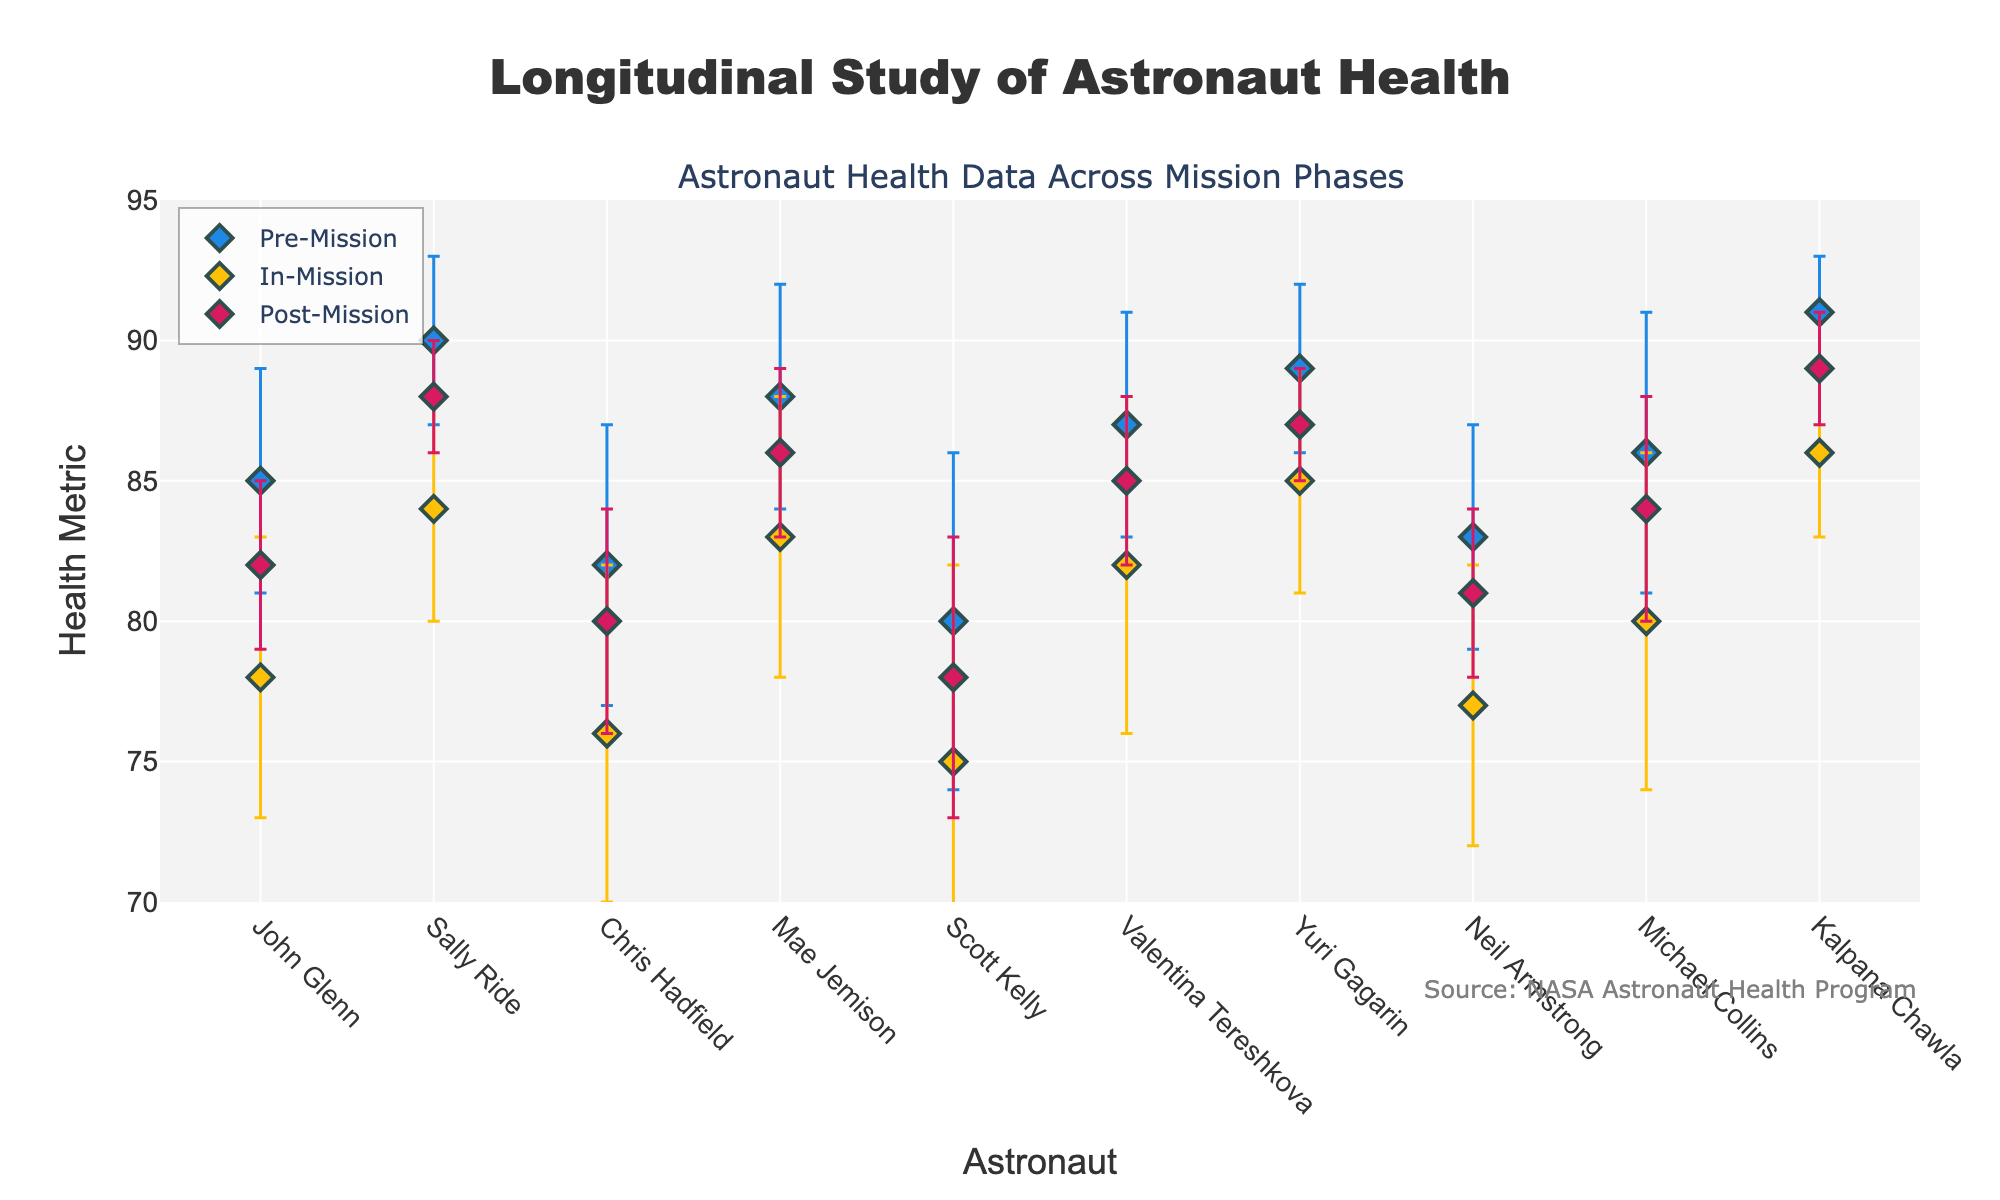What is the title of the figure? The title of the figure is shown at the top and reads "Longitudinal Study of Astronaut Health".
Answer: Longitudinal Study of Astronaut Health Which astronaut has the highest "Pre-Mission" health metric? Looking at the "Pre-Mission" data points, Kalpana Chawla has the highest value of 91.
Answer: Kalpana Chawla What is the average health metric for "In-Mission" across all astronauts? Summing up the "In-Mission" health metrics (78, 84, 76, 83, 75, 82, 85, 77, 80, 86) and then dividing by the number of data points (10), we get an average of (78+84+76+83+75+82+85+77+80+86)/10 = 80.6.
Answer: 80.6 Which mission has the largest error bar for "Post-Mission"? The largest "Post-Mission" error bar can be seen by comparing the error lengths; Scott Kelly has the largest error bar of 5.
Answer: Scott Kelly How does the "Post-Mission" health metric of Chris Hadfield compare to his "Pre-Mission" health metric? Chris Hadfield's "Pre-Mission" health metric is 82, and his "Post-Mission" health metric is 80. Comparing these two provides a difference of 82 - 80 = 2, indicating a decrease.
Answer: Decrease by 2 What is the range of the "Pre-Mission" health metrics? The highest "Pre-Mission" value is 91 (Kalpana Chawla), and the lowest is 80 (Scott Kelly). The range is calculated as 91 - 80 = 11.
Answer: 11 Which phase—"Pre-Mission", "In-Mission", or "Post-Mission"—generally shows the lowest health metrics? By observing the scatter plot, the "In-Mission" phase consistently shows lower health metrics across almost all astronauts compared to "Pre-Mission" and "Post-Mission".
Answer: In-Mission Which astronaut shows the smallest change in health metrics between "Pre-Mission" and "Post-Mission"? Looking at the differences between "Pre-Mission" and "Post-Mission" values, Kalpana Chawla shows the smallest change with "Pre-Mission" at 91 and "Post-Mission" at 89, a difference of only 2.
Answer: Kalpana Chawla 